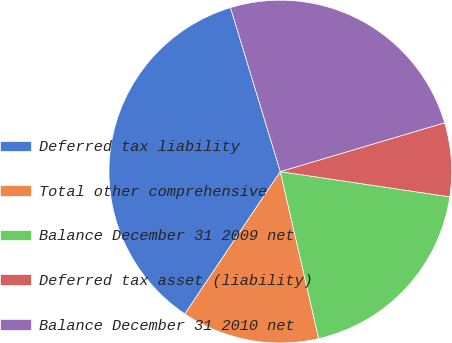<chart> <loc_0><loc_0><loc_500><loc_500><pie_chart><fcel>Deferred tax liability<fcel>Total other comprehensive<fcel>Balance December 31 2009 net<fcel>Deferred tax asset (liability)<fcel>Balance December 31 2010 net<nl><fcel>35.9%<fcel>13.0%<fcel>19.05%<fcel>6.95%<fcel>25.1%<nl></chart> 